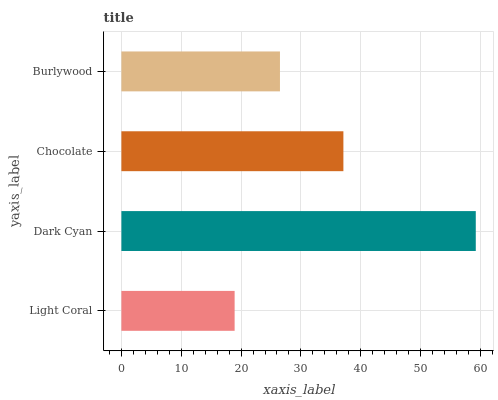Is Light Coral the minimum?
Answer yes or no. Yes. Is Dark Cyan the maximum?
Answer yes or no. Yes. Is Chocolate the minimum?
Answer yes or no. No. Is Chocolate the maximum?
Answer yes or no. No. Is Dark Cyan greater than Chocolate?
Answer yes or no. Yes. Is Chocolate less than Dark Cyan?
Answer yes or no. Yes. Is Chocolate greater than Dark Cyan?
Answer yes or no. No. Is Dark Cyan less than Chocolate?
Answer yes or no. No. Is Chocolate the high median?
Answer yes or no. Yes. Is Burlywood the low median?
Answer yes or no. Yes. Is Burlywood the high median?
Answer yes or no. No. Is Light Coral the low median?
Answer yes or no. No. 